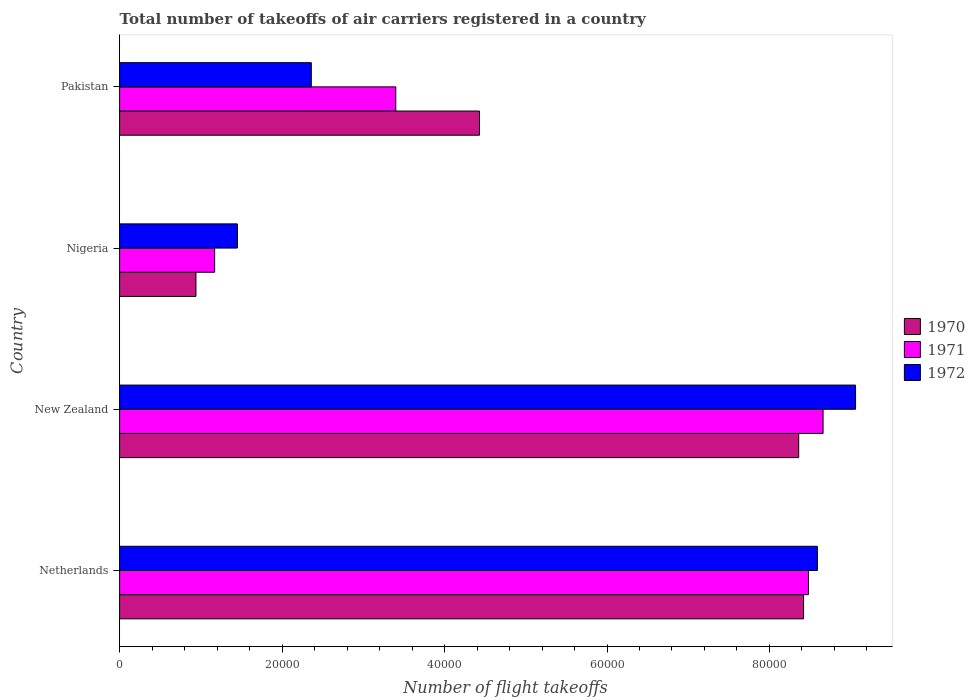Are the number of bars on each tick of the Y-axis equal?
Your response must be concise. Yes. How many bars are there on the 1st tick from the top?
Offer a very short reply. 3. How many bars are there on the 2nd tick from the bottom?
Your answer should be compact. 3. In how many cases, is the number of bars for a given country not equal to the number of legend labels?
Make the answer very short. 0. What is the total number of flight takeoffs in 1971 in Pakistan?
Give a very brief answer. 3.40e+04. Across all countries, what is the maximum total number of flight takeoffs in 1972?
Give a very brief answer. 9.06e+04. Across all countries, what is the minimum total number of flight takeoffs in 1970?
Provide a short and direct response. 9400. In which country was the total number of flight takeoffs in 1971 maximum?
Ensure brevity in your answer.  New Zealand. In which country was the total number of flight takeoffs in 1971 minimum?
Provide a succinct answer. Nigeria. What is the total total number of flight takeoffs in 1971 in the graph?
Provide a short and direct response. 2.17e+05. What is the difference between the total number of flight takeoffs in 1970 in New Zealand and that in Nigeria?
Your answer should be very brief. 7.42e+04. What is the difference between the total number of flight takeoffs in 1971 in New Zealand and the total number of flight takeoffs in 1970 in Pakistan?
Ensure brevity in your answer.  4.23e+04. What is the average total number of flight takeoffs in 1970 per country?
Your answer should be very brief. 5.54e+04. What is the difference between the total number of flight takeoffs in 1972 and total number of flight takeoffs in 1970 in Netherlands?
Ensure brevity in your answer.  1700. In how many countries, is the total number of flight takeoffs in 1970 greater than 8000 ?
Provide a succinct answer. 4. What is the ratio of the total number of flight takeoffs in 1972 in Netherlands to that in New Zealand?
Provide a short and direct response. 0.95. Is the total number of flight takeoffs in 1970 in New Zealand less than that in Nigeria?
Keep it short and to the point. No. What is the difference between the highest and the second highest total number of flight takeoffs in 1970?
Give a very brief answer. 600. What is the difference between the highest and the lowest total number of flight takeoffs in 1971?
Make the answer very short. 7.49e+04. In how many countries, is the total number of flight takeoffs in 1972 greater than the average total number of flight takeoffs in 1972 taken over all countries?
Your response must be concise. 2. What does the 3rd bar from the top in Nigeria represents?
Keep it short and to the point. 1970. Is it the case that in every country, the sum of the total number of flight takeoffs in 1971 and total number of flight takeoffs in 1970 is greater than the total number of flight takeoffs in 1972?
Keep it short and to the point. Yes. Are all the bars in the graph horizontal?
Provide a succinct answer. Yes. How many countries are there in the graph?
Offer a terse response. 4. What is the difference between two consecutive major ticks on the X-axis?
Ensure brevity in your answer.  2.00e+04. How many legend labels are there?
Your answer should be very brief. 3. How are the legend labels stacked?
Offer a very short reply. Vertical. What is the title of the graph?
Your answer should be compact. Total number of takeoffs of air carriers registered in a country. What is the label or title of the X-axis?
Ensure brevity in your answer.  Number of flight takeoffs. What is the Number of flight takeoffs of 1970 in Netherlands?
Offer a terse response. 8.42e+04. What is the Number of flight takeoffs in 1971 in Netherlands?
Your answer should be compact. 8.48e+04. What is the Number of flight takeoffs of 1972 in Netherlands?
Provide a short and direct response. 8.59e+04. What is the Number of flight takeoffs of 1970 in New Zealand?
Make the answer very short. 8.36e+04. What is the Number of flight takeoffs of 1971 in New Zealand?
Give a very brief answer. 8.66e+04. What is the Number of flight takeoffs of 1972 in New Zealand?
Provide a short and direct response. 9.06e+04. What is the Number of flight takeoffs in 1970 in Nigeria?
Ensure brevity in your answer.  9400. What is the Number of flight takeoffs of 1971 in Nigeria?
Your answer should be very brief. 1.17e+04. What is the Number of flight takeoffs of 1972 in Nigeria?
Offer a terse response. 1.45e+04. What is the Number of flight takeoffs of 1970 in Pakistan?
Make the answer very short. 4.43e+04. What is the Number of flight takeoffs in 1971 in Pakistan?
Your answer should be very brief. 3.40e+04. What is the Number of flight takeoffs of 1972 in Pakistan?
Offer a very short reply. 2.36e+04. Across all countries, what is the maximum Number of flight takeoffs in 1970?
Offer a very short reply. 8.42e+04. Across all countries, what is the maximum Number of flight takeoffs in 1971?
Ensure brevity in your answer.  8.66e+04. Across all countries, what is the maximum Number of flight takeoffs in 1972?
Keep it short and to the point. 9.06e+04. Across all countries, what is the minimum Number of flight takeoffs in 1970?
Give a very brief answer. 9400. Across all countries, what is the minimum Number of flight takeoffs of 1971?
Provide a short and direct response. 1.17e+04. Across all countries, what is the minimum Number of flight takeoffs in 1972?
Your answer should be very brief. 1.45e+04. What is the total Number of flight takeoffs in 1970 in the graph?
Keep it short and to the point. 2.22e+05. What is the total Number of flight takeoffs in 1971 in the graph?
Give a very brief answer. 2.17e+05. What is the total Number of flight takeoffs of 1972 in the graph?
Provide a short and direct response. 2.15e+05. What is the difference between the Number of flight takeoffs in 1970 in Netherlands and that in New Zealand?
Make the answer very short. 600. What is the difference between the Number of flight takeoffs of 1971 in Netherlands and that in New Zealand?
Offer a very short reply. -1800. What is the difference between the Number of flight takeoffs of 1972 in Netherlands and that in New Zealand?
Keep it short and to the point. -4700. What is the difference between the Number of flight takeoffs in 1970 in Netherlands and that in Nigeria?
Keep it short and to the point. 7.48e+04. What is the difference between the Number of flight takeoffs in 1971 in Netherlands and that in Nigeria?
Your answer should be compact. 7.31e+04. What is the difference between the Number of flight takeoffs in 1972 in Netherlands and that in Nigeria?
Offer a terse response. 7.14e+04. What is the difference between the Number of flight takeoffs of 1970 in Netherlands and that in Pakistan?
Keep it short and to the point. 3.99e+04. What is the difference between the Number of flight takeoffs in 1971 in Netherlands and that in Pakistan?
Your answer should be compact. 5.08e+04. What is the difference between the Number of flight takeoffs of 1972 in Netherlands and that in Pakistan?
Give a very brief answer. 6.23e+04. What is the difference between the Number of flight takeoffs of 1970 in New Zealand and that in Nigeria?
Offer a very short reply. 7.42e+04. What is the difference between the Number of flight takeoffs in 1971 in New Zealand and that in Nigeria?
Make the answer very short. 7.49e+04. What is the difference between the Number of flight takeoffs in 1972 in New Zealand and that in Nigeria?
Your answer should be very brief. 7.61e+04. What is the difference between the Number of flight takeoffs in 1970 in New Zealand and that in Pakistan?
Provide a short and direct response. 3.93e+04. What is the difference between the Number of flight takeoffs in 1971 in New Zealand and that in Pakistan?
Provide a succinct answer. 5.26e+04. What is the difference between the Number of flight takeoffs in 1972 in New Zealand and that in Pakistan?
Give a very brief answer. 6.70e+04. What is the difference between the Number of flight takeoffs of 1970 in Nigeria and that in Pakistan?
Offer a terse response. -3.49e+04. What is the difference between the Number of flight takeoffs in 1971 in Nigeria and that in Pakistan?
Provide a short and direct response. -2.23e+04. What is the difference between the Number of flight takeoffs in 1972 in Nigeria and that in Pakistan?
Your answer should be compact. -9100. What is the difference between the Number of flight takeoffs in 1970 in Netherlands and the Number of flight takeoffs in 1971 in New Zealand?
Your answer should be very brief. -2400. What is the difference between the Number of flight takeoffs of 1970 in Netherlands and the Number of flight takeoffs of 1972 in New Zealand?
Make the answer very short. -6400. What is the difference between the Number of flight takeoffs of 1971 in Netherlands and the Number of flight takeoffs of 1972 in New Zealand?
Ensure brevity in your answer.  -5800. What is the difference between the Number of flight takeoffs of 1970 in Netherlands and the Number of flight takeoffs of 1971 in Nigeria?
Your answer should be very brief. 7.25e+04. What is the difference between the Number of flight takeoffs of 1970 in Netherlands and the Number of flight takeoffs of 1972 in Nigeria?
Provide a succinct answer. 6.97e+04. What is the difference between the Number of flight takeoffs of 1971 in Netherlands and the Number of flight takeoffs of 1972 in Nigeria?
Make the answer very short. 7.03e+04. What is the difference between the Number of flight takeoffs of 1970 in Netherlands and the Number of flight takeoffs of 1971 in Pakistan?
Keep it short and to the point. 5.02e+04. What is the difference between the Number of flight takeoffs in 1970 in Netherlands and the Number of flight takeoffs in 1972 in Pakistan?
Offer a terse response. 6.06e+04. What is the difference between the Number of flight takeoffs in 1971 in Netherlands and the Number of flight takeoffs in 1972 in Pakistan?
Keep it short and to the point. 6.12e+04. What is the difference between the Number of flight takeoffs of 1970 in New Zealand and the Number of flight takeoffs of 1971 in Nigeria?
Your response must be concise. 7.19e+04. What is the difference between the Number of flight takeoffs in 1970 in New Zealand and the Number of flight takeoffs in 1972 in Nigeria?
Offer a very short reply. 6.91e+04. What is the difference between the Number of flight takeoffs of 1971 in New Zealand and the Number of flight takeoffs of 1972 in Nigeria?
Your response must be concise. 7.21e+04. What is the difference between the Number of flight takeoffs in 1970 in New Zealand and the Number of flight takeoffs in 1971 in Pakistan?
Provide a short and direct response. 4.96e+04. What is the difference between the Number of flight takeoffs in 1970 in New Zealand and the Number of flight takeoffs in 1972 in Pakistan?
Give a very brief answer. 6.00e+04. What is the difference between the Number of flight takeoffs of 1971 in New Zealand and the Number of flight takeoffs of 1972 in Pakistan?
Offer a terse response. 6.30e+04. What is the difference between the Number of flight takeoffs in 1970 in Nigeria and the Number of flight takeoffs in 1971 in Pakistan?
Offer a terse response. -2.46e+04. What is the difference between the Number of flight takeoffs of 1970 in Nigeria and the Number of flight takeoffs of 1972 in Pakistan?
Your answer should be very brief. -1.42e+04. What is the difference between the Number of flight takeoffs of 1971 in Nigeria and the Number of flight takeoffs of 1972 in Pakistan?
Ensure brevity in your answer.  -1.19e+04. What is the average Number of flight takeoffs in 1970 per country?
Provide a short and direct response. 5.54e+04. What is the average Number of flight takeoffs in 1971 per country?
Offer a very short reply. 5.43e+04. What is the average Number of flight takeoffs of 1972 per country?
Keep it short and to the point. 5.36e+04. What is the difference between the Number of flight takeoffs in 1970 and Number of flight takeoffs in 1971 in Netherlands?
Give a very brief answer. -600. What is the difference between the Number of flight takeoffs in 1970 and Number of flight takeoffs in 1972 in Netherlands?
Offer a very short reply. -1700. What is the difference between the Number of flight takeoffs of 1971 and Number of flight takeoffs of 1972 in Netherlands?
Make the answer very short. -1100. What is the difference between the Number of flight takeoffs in 1970 and Number of flight takeoffs in 1971 in New Zealand?
Offer a terse response. -3000. What is the difference between the Number of flight takeoffs in 1970 and Number of flight takeoffs in 1972 in New Zealand?
Your response must be concise. -7000. What is the difference between the Number of flight takeoffs of 1971 and Number of flight takeoffs of 1972 in New Zealand?
Make the answer very short. -4000. What is the difference between the Number of flight takeoffs of 1970 and Number of flight takeoffs of 1971 in Nigeria?
Your answer should be compact. -2300. What is the difference between the Number of flight takeoffs in 1970 and Number of flight takeoffs in 1972 in Nigeria?
Keep it short and to the point. -5100. What is the difference between the Number of flight takeoffs of 1971 and Number of flight takeoffs of 1972 in Nigeria?
Offer a terse response. -2800. What is the difference between the Number of flight takeoffs of 1970 and Number of flight takeoffs of 1971 in Pakistan?
Give a very brief answer. 1.03e+04. What is the difference between the Number of flight takeoffs of 1970 and Number of flight takeoffs of 1972 in Pakistan?
Your response must be concise. 2.07e+04. What is the difference between the Number of flight takeoffs in 1971 and Number of flight takeoffs in 1972 in Pakistan?
Give a very brief answer. 1.04e+04. What is the ratio of the Number of flight takeoffs in 1971 in Netherlands to that in New Zealand?
Offer a terse response. 0.98. What is the ratio of the Number of flight takeoffs of 1972 in Netherlands to that in New Zealand?
Ensure brevity in your answer.  0.95. What is the ratio of the Number of flight takeoffs in 1970 in Netherlands to that in Nigeria?
Your answer should be very brief. 8.96. What is the ratio of the Number of flight takeoffs in 1971 in Netherlands to that in Nigeria?
Your answer should be compact. 7.25. What is the ratio of the Number of flight takeoffs in 1972 in Netherlands to that in Nigeria?
Your answer should be compact. 5.92. What is the ratio of the Number of flight takeoffs of 1970 in Netherlands to that in Pakistan?
Ensure brevity in your answer.  1.9. What is the ratio of the Number of flight takeoffs in 1971 in Netherlands to that in Pakistan?
Your answer should be very brief. 2.49. What is the ratio of the Number of flight takeoffs of 1972 in Netherlands to that in Pakistan?
Provide a short and direct response. 3.64. What is the ratio of the Number of flight takeoffs in 1970 in New Zealand to that in Nigeria?
Offer a terse response. 8.89. What is the ratio of the Number of flight takeoffs in 1971 in New Zealand to that in Nigeria?
Make the answer very short. 7.4. What is the ratio of the Number of flight takeoffs of 1972 in New Zealand to that in Nigeria?
Provide a short and direct response. 6.25. What is the ratio of the Number of flight takeoffs of 1970 in New Zealand to that in Pakistan?
Your answer should be very brief. 1.89. What is the ratio of the Number of flight takeoffs in 1971 in New Zealand to that in Pakistan?
Provide a short and direct response. 2.55. What is the ratio of the Number of flight takeoffs of 1972 in New Zealand to that in Pakistan?
Keep it short and to the point. 3.84. What is the ratio of the Number of flight takeoffs of 1970 in Nigeria to that in Pakistan?
Provide a succinct answer. 0.21. What is the ratio of the Number of flight takeoffs in 1971 in Nigeria to that in Pakistan?
Provide a short and direct response. 0.34. What is the ratio of the Number of flight takeoffs in 1972 in Nigeria to that in Pakistan?
Offer a terse response. 0.61. What is the difference between the highest and the second highest Number of flight takeoffs of 1970?
Ensure brevity in your answer.  600. What is the difference between the highest and the second highest Number of flight takeoffs of 1971?
Make the answer very short. 1800. What is the difference between the highest and the second highest Number of flight takeoffs in 1972?
Ensure brevity in your answer.  4700. What is the difference between the highest and the lowest Number of flight takeoffs in 1970?
Your response must be concise. 7.48e+04. What is the difference between the highest and the lowest Number of flight takeoffs in 1971?
Your response must be concise. 7.49e+04. What is the difference between the highest and the lowest Number of flight takeoffs in 1972?
Provide a succinct answer. 7.61e+04. 